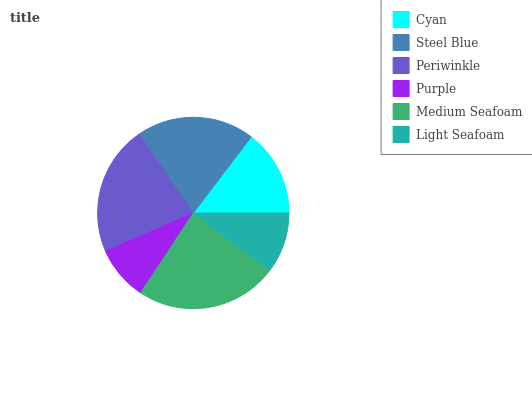Is Purple the minimum?
Answer yes or no. Yes. Is Medium Seafoam the maximum?
Answer yes or no. Yes. Is Steel Blue the minimum?
Answer yes or no. No. Is Steel Blue the maximum?
Answer yes or no. No. Is Steel Blue greater than Cyan?
Answer yes or no. Yes. Is Cyan less than Steel Blue?
Answer yes or no. Yes. Is Cyan greater than Steel Blue?
Answer yes or no. No. Is Steel Blue less than Cyan?
Answer yes or no. No. Is Steel Blue the high median?
Answer yes or no. Yes. Is Cyan the low median?
Answer yes or no. Yes. Is Periwinkle the high median?
Answer yes or no. No. Is Purple the low median?
Answer yes or no. No. 